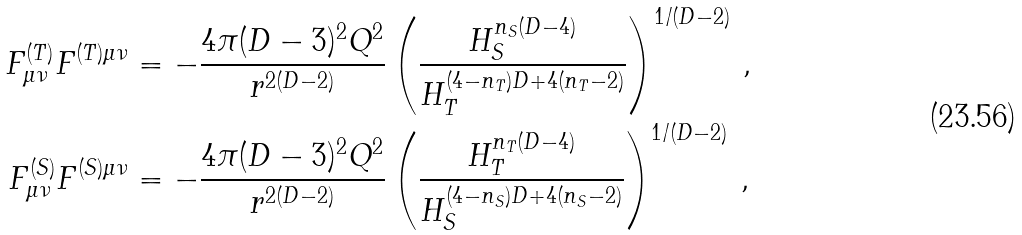<formula> <loc_0><loc_0><loc_500><loc_500>F ^ { ( T ) } _ { \mu \nu } F ^ { ( T ) \mu \nu } & = - \frac { 4 \pi ( D - 3 ) ^ { 2 } Q ^ { 2 } } { r ^ { 2 ( D - 2 ) } } \left ( \frac { H _ { S } ^ { n _ { S } ( D - 4 ) } } { H _ { T } ^ { ( 4 - n _ { T } ) D + 4 ( n _ { T } - 2 ) } } \right ) ^ { 1 / ( D - 2 ) } \, , \\ F ^ { ( S ) } _ { \mu \nu } F ^ { ( S ) \mu \nu } & = - \frac { 4 \pi ( D - 3 ) ^ { 2 } Q ^ { 2 } } { r ^ { 2 ( D - 2 ) } } \left ( \frac { H _ { T } ^ { n _ { T } ( D - 4 ) } } { H _ { S } ^ { ( 4 - n _ { S } ) D + 4 ( n _ { S } - 2 ) } } \right ) ^ { 1 / ( D - 2 ) } \, ,</formula> 